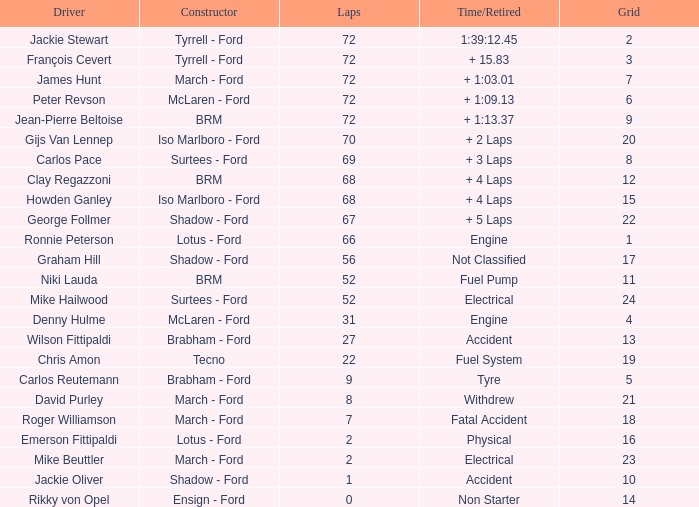What is the foremost lap that had a tyre period? 9.0. 